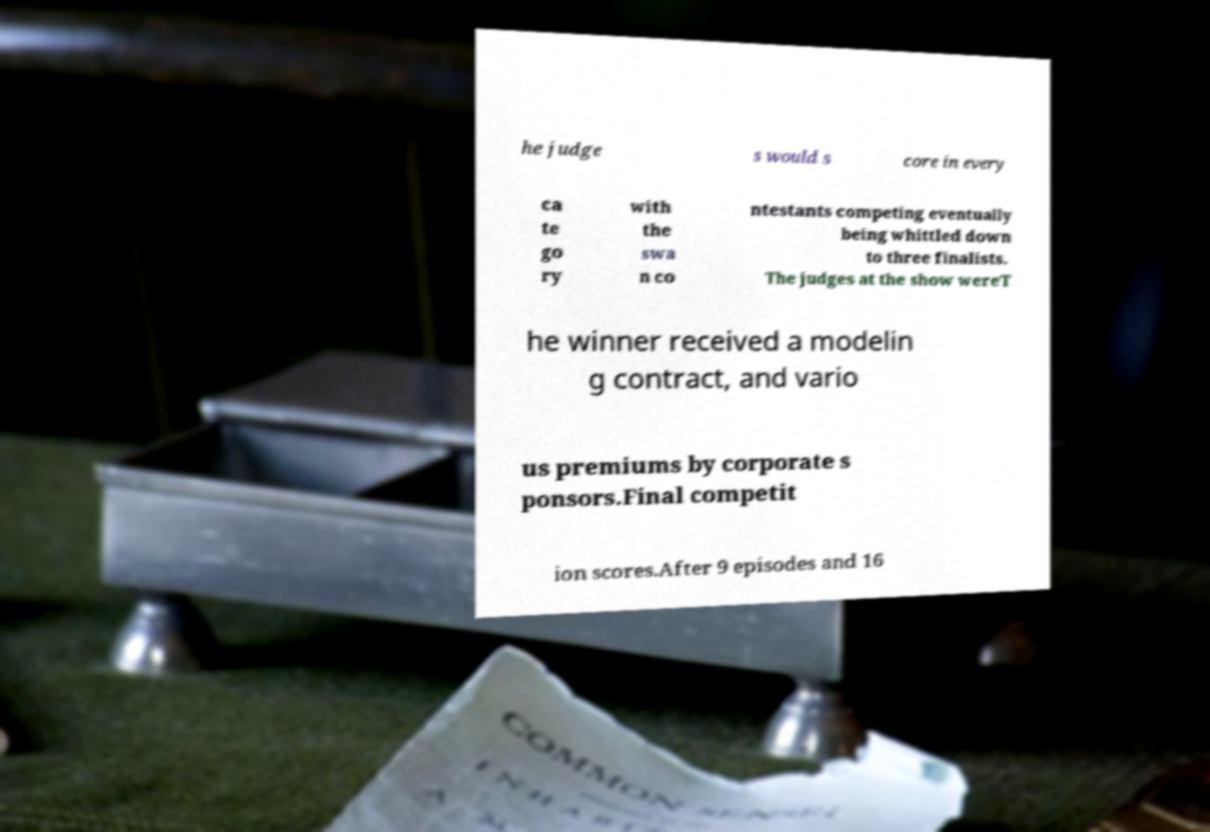Can you read and provide the text displayed in the image?This photo seems to have some interesting text. Can you extract and type it out for me? he judge s would s core in every ca te go ry with the swa n co ntestants competing eventually being whittled down to three finalists. The judges at the show wereT he winner received a modelin g contract, and vario us premiums by corporate s ponsors.Final competit ion scores.After 9 episodes and 16 